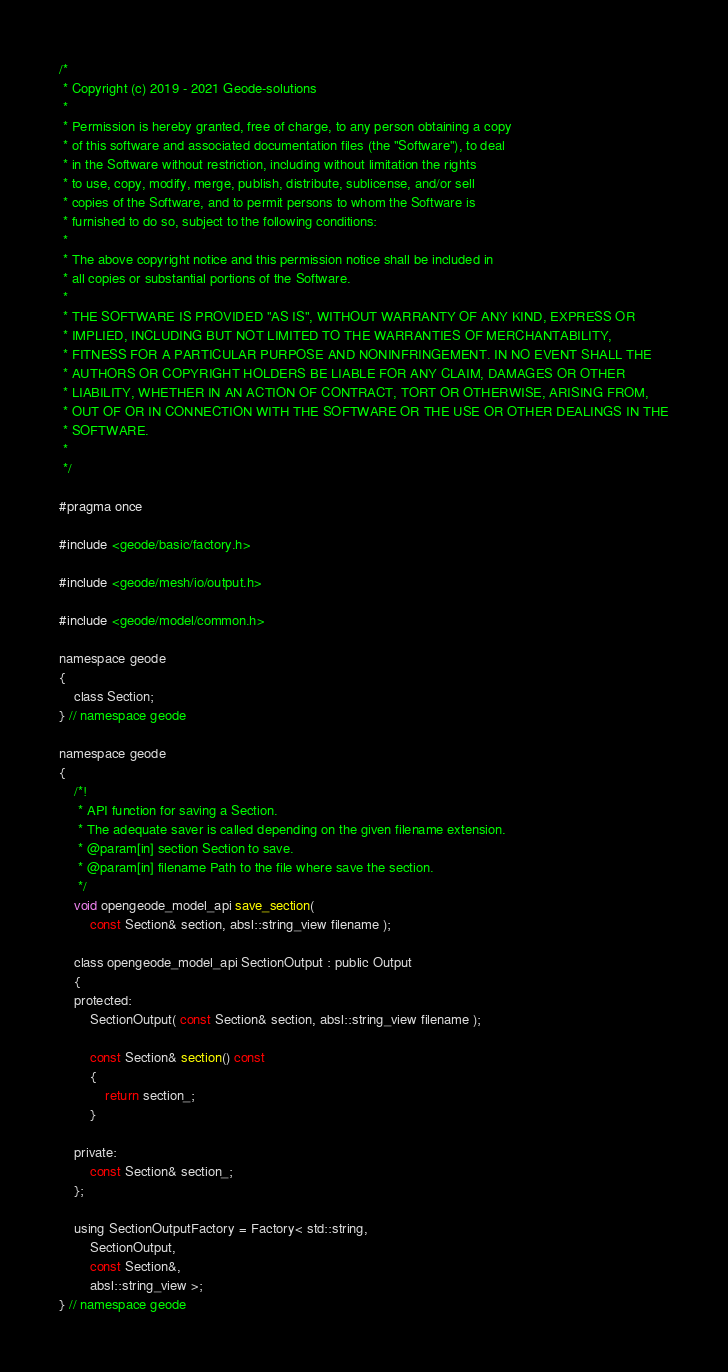Convert code to text. <code><loc_0><loc_0><loc_500><loc_500><_C_>/*
 * Copyright (c) 2019 - 2021 Geode-solutions
 *
 * Permission is hereby granted, free of charge, to any person obtaining a copy
 * of this software and associated documentation files (the "Software"), to deal
 * in the Software without restriction, including without limitation the rights
 * to use, copy, modify, merge, publish, distribute, sublicense, and/or sell
 * copies of the Software, and to permit persons to whom the Software is
 * furnished to do so, subject to the following conditions:
 *
 * The above copyright notice and this permission notice shall be included in
 * all copies or substantial portions of the Software.
 *
 * THE SOFTWARE IS PROVIDED "AS IS", WITHOUT WARRANTY OF ANY KIND, EXPRESS OR
 * IMPLIED, INCLUDING BUT NOT LIMITED TO THE WARRANTIES OF MERCHANTABILITY,
 * FITNESS FOR A PARTICULAR PURPOSE AND NONINFRINGEMENT. IN NO EVENT SHALL THE
 * AUTHORS OR COPYRIGHT HOLDERS BE LIABLE FOR ANY CLAIM, DAMAGES OR OTHER
 * LIABILITY, WHETHER IN AN ACTION OF CONTRACT, TORT OR OTHERWISE, ARISING FROM,
 * OUT OF OR IN CONNECTION WITH THE SOFTWARE OR THE USE OR OTHER DEALINGS IN THE
 * SOFTWARE.
 *
 */

#pragma once

#include <geode/basic/factory.h>

#include <geode/mesh/io/output.h>

#include <geode/model/common.h>

namespace geode
{
    class Section;
} // namespace geode

namespace geode
{
    /*!
     * API function for saving a Section.
     * The adequate saver is called depending on the given filename extension.
     * @param[in] section Section to save.
     * @param[in] filename Path to the file where save the section.
     */
    void opengeode_model_api save_section(
        const Section& section, absl::string_view filename );

    class opengeode_model_api SectionOutput : public Output
    {
    protected:
        SectionOutput( const Section& section, absl::string_view filename );

        const Section& section() const
        {
            return section_;
        }

    private:
        const Section& section_;
    };

    using SectionOutputFactory = Factory< std::string,
        SectionOutput,
        const Section&,
        absl::string_view >;
} // namespace geode
</code> 